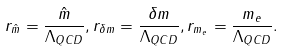<formula> <loc_0><loc_0><loc_500><loc_500>r _ { \hat { m } } = \frac { \hat { m } } { \Lambda _ { Q C D } } , r _ { \delta { m } } = \frac { \delta { m } } { \Lambda _ { Q C D } } , r _ { m _ { e } } = \frac { m _ { e } } { \Lambda _ { Q C D } } .</formula> 